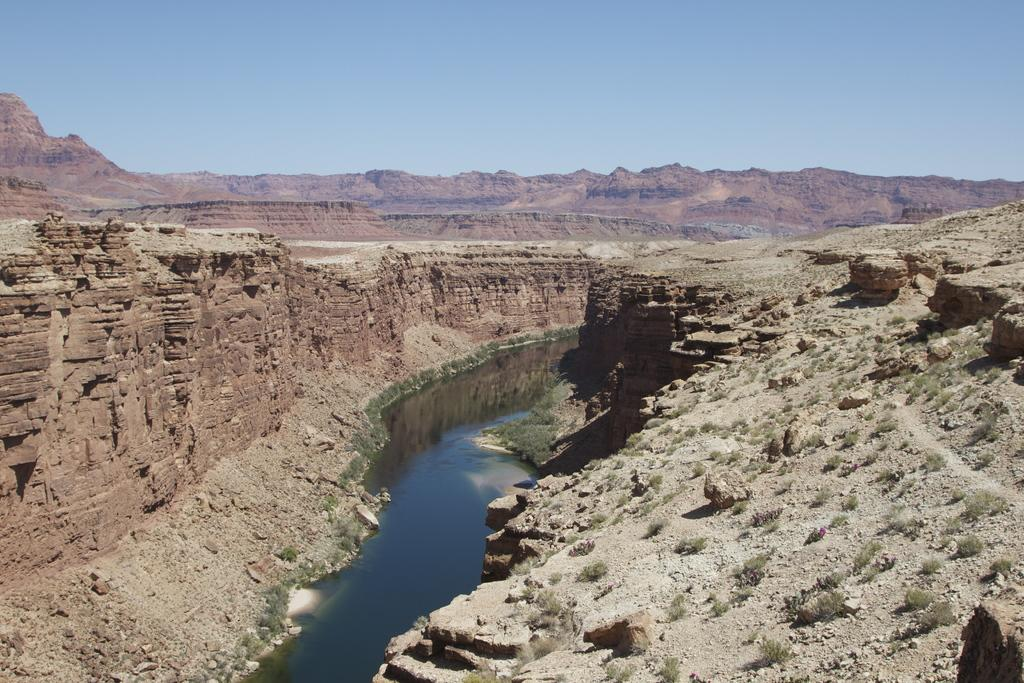What type of terrain is visible in the image? There is ground visible in the image, with grass on the ground. What other natural elements can be seen in the image? There are rocks and water visible in the image. What is the landscape feature in the background of the image? There is a mountain in the background of the image. What else can be seen in the background of the image? The sky is visible in the background of the image. How many giraffes can be seen in the image? There are no giraffes present in the image. What type of education is being offered in the image? There is no indication of any educational activity or institution in the image. 